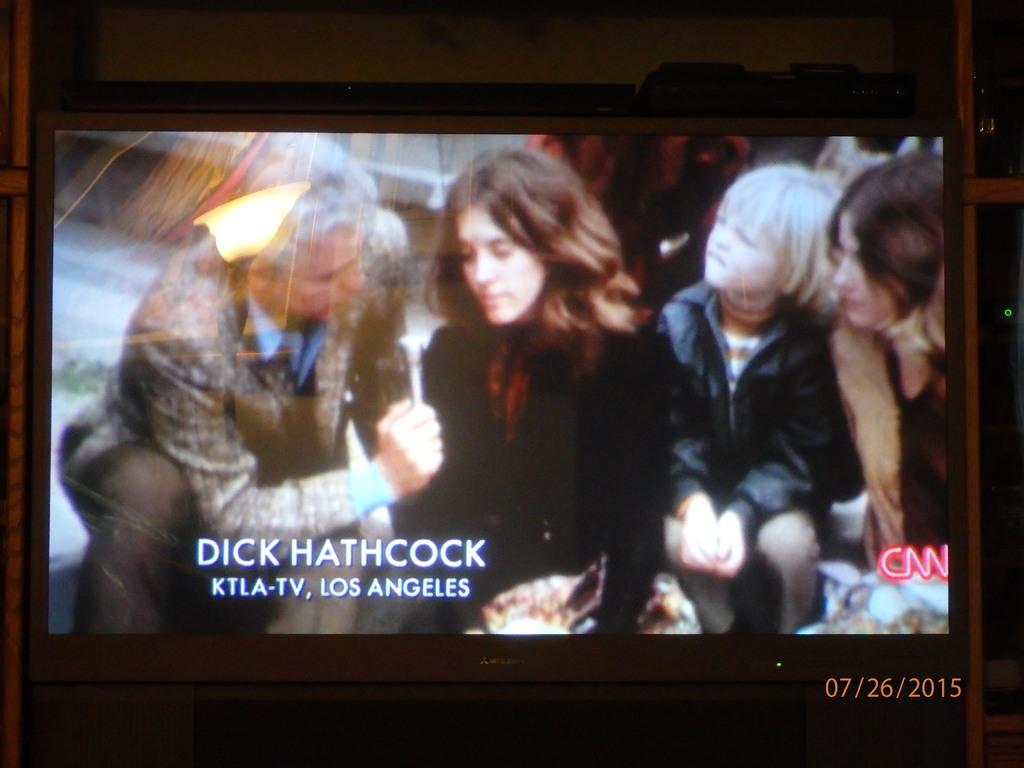What television network is this?
Make the answer very short. Cnn. 